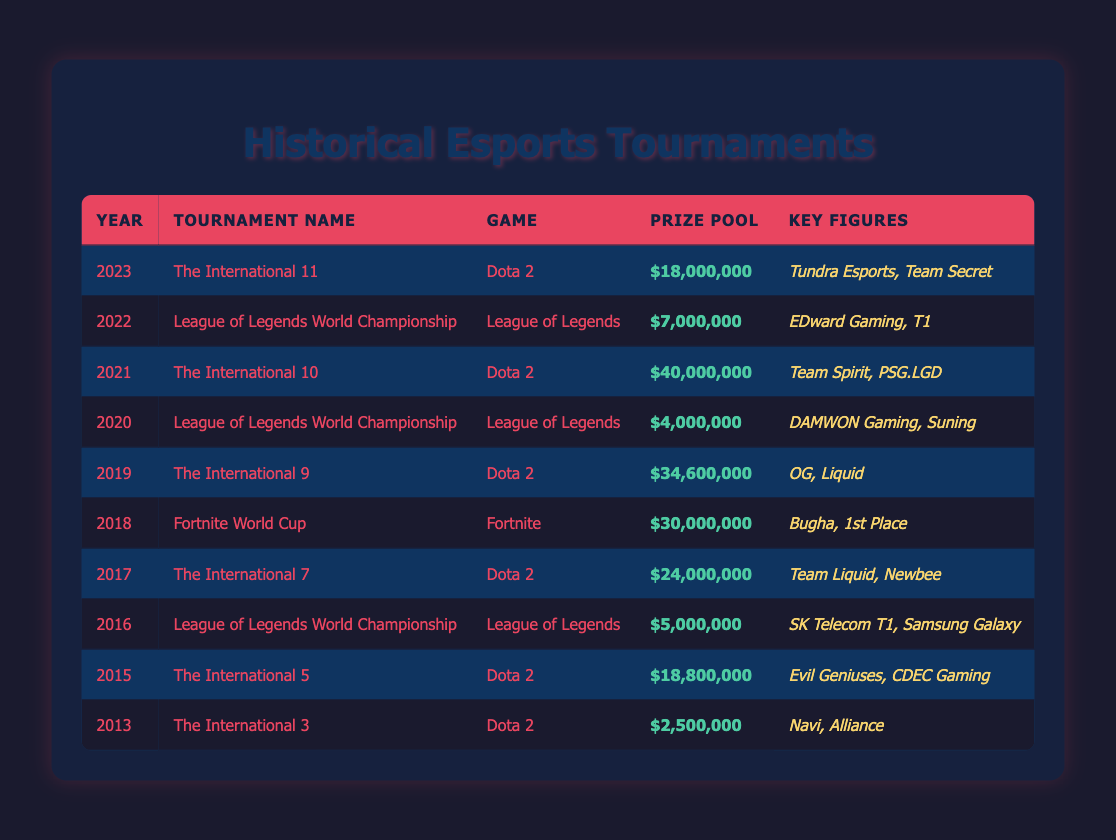What was the prize pool for The International 5? The prize pool for The International 5 in 2015 is directly mentioned in the table, where it states the amount as $18,800,000.
Answer: $18,800,000 Which game had the highest prize pool in the table? By comparing the prize pools listed for each tournament, Fortnite World Cup in 2018 has the highest prize pool at $30,000,000, which is greater than all the other tournament prize pools listed.
Answer: Fortnite World Cup What was the total prize pool for Dota 2 tournaments from 2013 to 2023? To find the total prize pool for all Dota 2 tournaments, I will sum up the prize pools from the corresponding rows: $2,500,000 (2013) + $18,800,000 (2015) + $25,000,000 (2017) + $34,600,000 (2019) + $40,000,000 (2021) + $18,000,000 (2023) = $139,900,000.
Answer: $139,900,000 Did any other game besides Dota 2 and League of Legends appear in this table? Checking the tournament names, Fortnite is the only other game mentioned apart from Dota 2 and League of Legends, which confirms that the only other game featured is Fortnite.
Answer: Yes Which year had the lowest prize pool, and what was the amount? By examining the prize pools in each row, the lowest prize pool is found in 2013 for The International 3 at $2,500,000, compared to all other tournaments which have higher amounts.
Answer: 2013, $2,500,000 How much was the average prize pool for the League of Legends World Championship across the years? The League of Legends World Championship occurred in 2016, 2020, and 2022. Their prize pools are $5,000,000 (2016), $4,000,000 (2020), and $7,000,000 (2022). I will sum these amounts: $5,000,000 + $4,000,000 + $7,000,000 = $16,000,000 and then divide by the number of tournaments (3), resulting in an average of $5,333,333.33, which rounds down to $5,333,333.
Answer: $5,333,333 Which key figures are associated with the winning team of The International 10? From the table entry for The International 10 in 2021, the key figures listed are Team Spirit and PSG.LGD, as they are the notable teams referenced during that tournament.
Answer: Team Spirit, PSG.LGD Was the prize pool for The International 11 higher than that of The International 9? By comparing the prize pools listed for both tournaments, The International 11 (2023) had a prize pool of $18,000,000 while The International 9 (2019) had a prize pool of $34,600,000, making 11 lower than 9.
Answer: No 